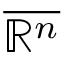Convert formula to latex. <formula><loc_0><loc_0><loc_500><loc_500>\overline { { \mathbb { R } ^ { n } } }</formula> 